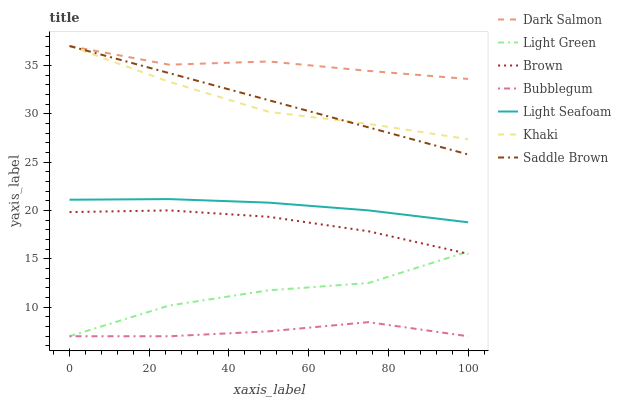Does Bubblegum have the minimum area under the curve?
Answer yes or no. Yes. Does Dark Salmon have the maximum area under the curve?
Answer yes or no. Yes. Does Khaki have the minimum area under the curve?
Answer yes or no. No. Does Khaki have the maximum area under the curve?
Answer yes or no. No. Is Saddle Brown the smoothest?
Answer yes or no. Yes. Is Light Green the roughest?
Answer yes or no. Yes. Is Khaki the smoothest?
Answer yes or no. No. Is Khaki the roughest?
Answer yes or no. No. Does Bubblegum have the lowest value?
Answer yes or no. Yes. Does Khaki have the lowest value?
Answer yes or no. No. Does Saddle Brown have the highest value?
Answer yes or no. Yes. Does Bubblegum have the highest value?
Answer yes or no. No. Is Light Green less than Khaki?
Answer yes or no. Yes. Is Saddle Brown greater than Light Green?
Answer yes or no. Yes. Does Dark Salmon intersect Saddle Brown?
Answer yes or no. Yes. Is Dark Salmon less than Saddle Brown?
Answer yes or no. No. Is Dark Salmon greater than Saddle Brown?
Answer yes or no. No. Does Light Green intersect Khaki?
Answer yes or no. No. 